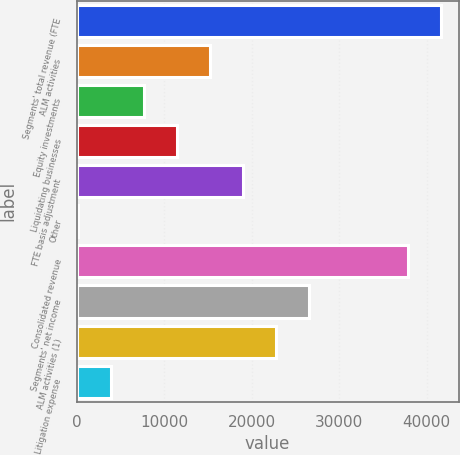Convert chart. <chart><loc_0><loc_0><loc_500><loc_500><bar_chart><fcel>Segments' total revenue (FTE<fcel>ALM activities<fcel>Equity investments<fcel>Liquidating businesses<fcel>FTE basis adjustment<fcel>Other<fcel>Consolidated revenue<fcel>Segments' net income<fcel>ALM activities (1)<fcel>Litigation expense<nl><fcel>41603.7<fcel>15224.8<fcel>7685.4<fcel>11455.1<fcel>18994.5<fcel>146<fcel>37834<fcel>26533.9<fcel>22764.2<fcel>3915.7<nl></chart> 